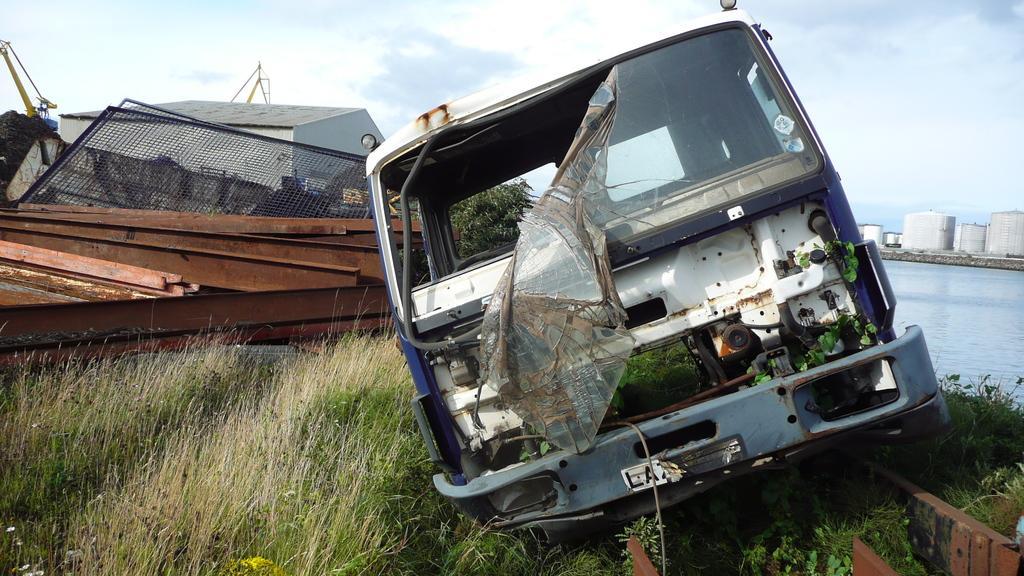How would you summarize this image in a sentence or two? In this picture we can see a crashed vehicle, grass and some objects on the ground and in the background we can see buildings, trees, water, sky. 